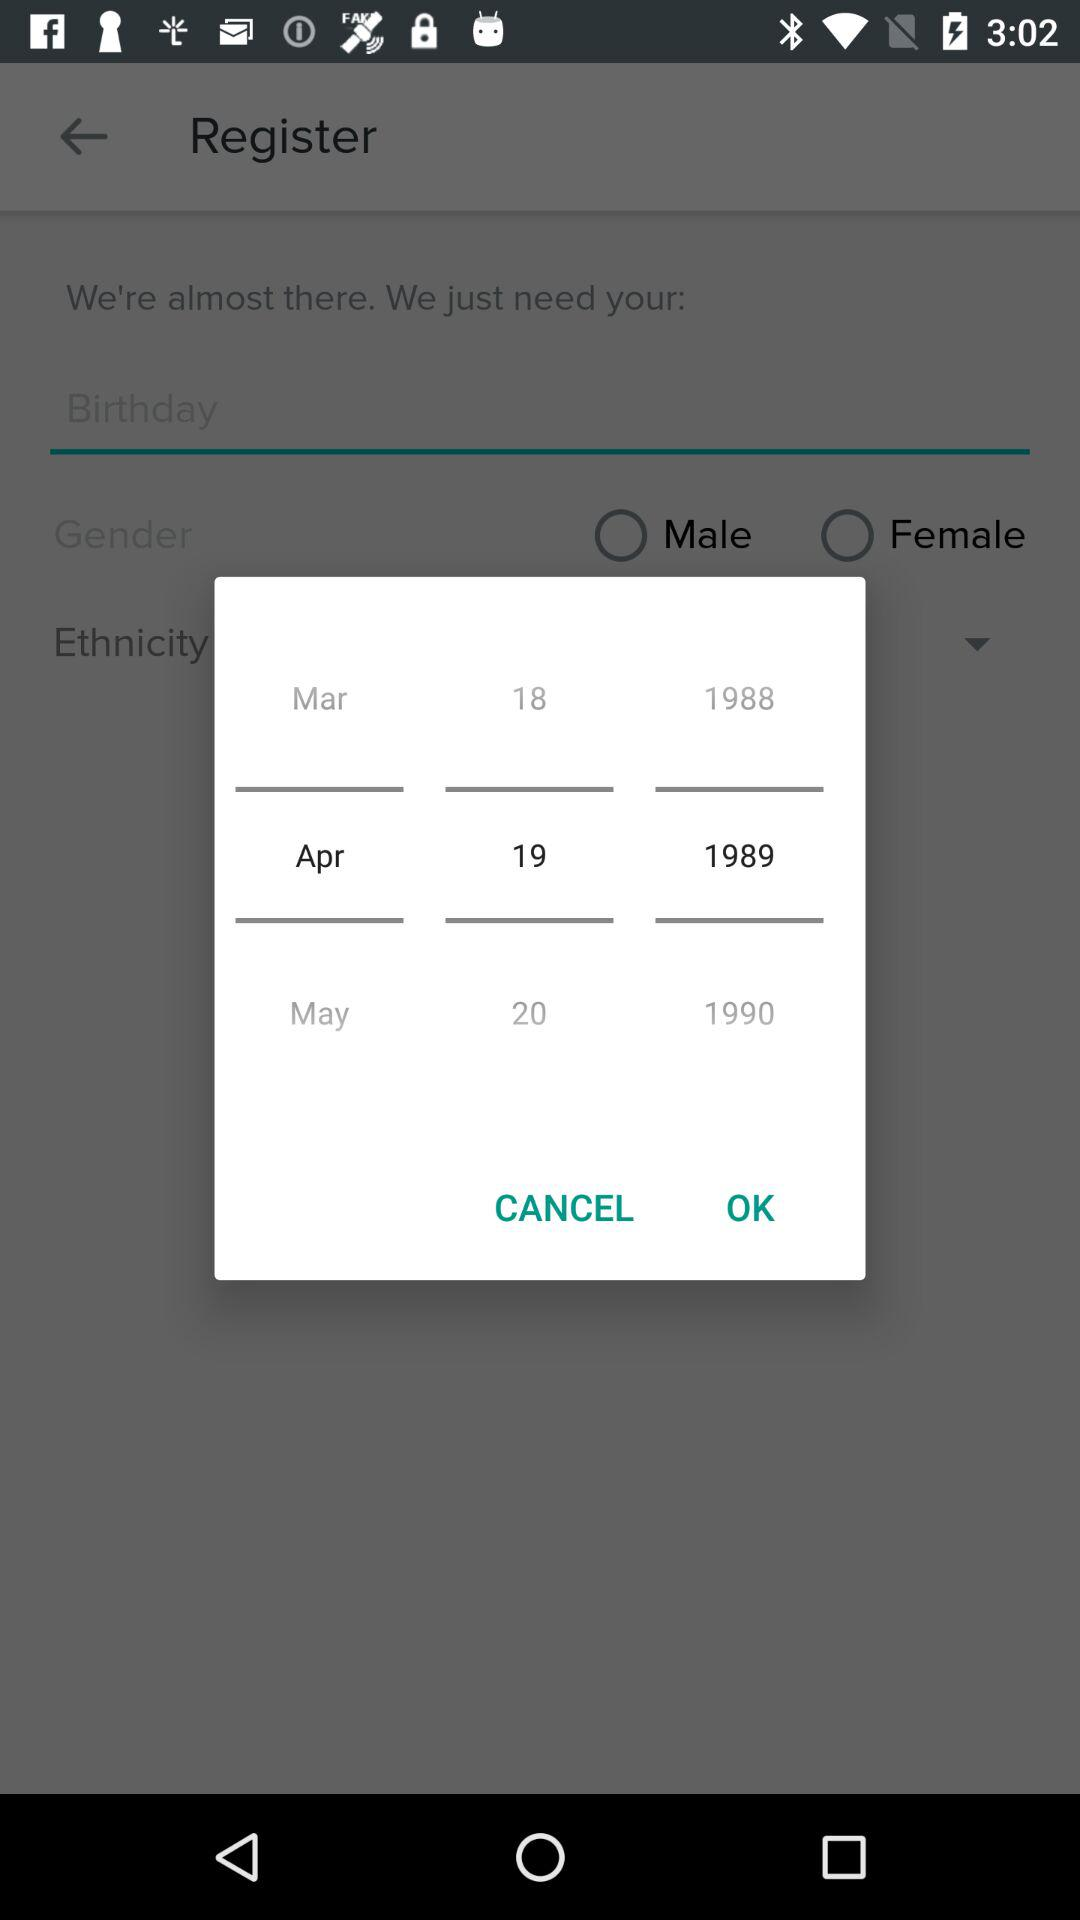How many years are shown in the calendar?
Answer the question using a single word or phrase. 3 